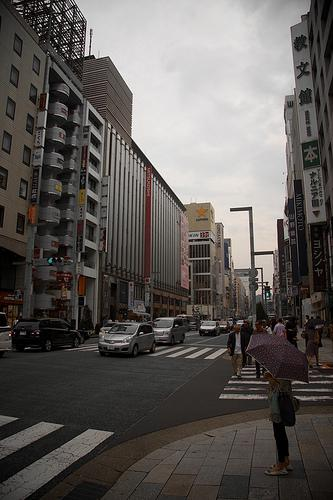Question: what type of vehicles are seen in photo?
Choices:
A. Automobiles.
B. Snowmobiles.
C. Scooters.
D. Mopeds.
Answer with the letter. Answer: A Question: what type of vehicle on left has its back to camera?
Choices:
A. Motorcycle.
B. Bicycle.
C. Mini van.
D. Go Cart.
Answer with the letter. Answer: C Question: where is this scene?
Choices:
A. The beach.
B. The mountains.
C. The doctor's office.
D. City street.
Answer with the letter. Answer: D Question: why would person use umbrella when it is not raining?
Choices:
A. For balance.
B. For show.
C. For shade.
D. They are pretentious.
Answer with the letter. Answer: C Question: how are the people in crosswalk transporting themselves?
Choices:
A. On bicycle.
B. By car.
C. By walking.
D. On scooter.
Answer with the letter. Answer: C 